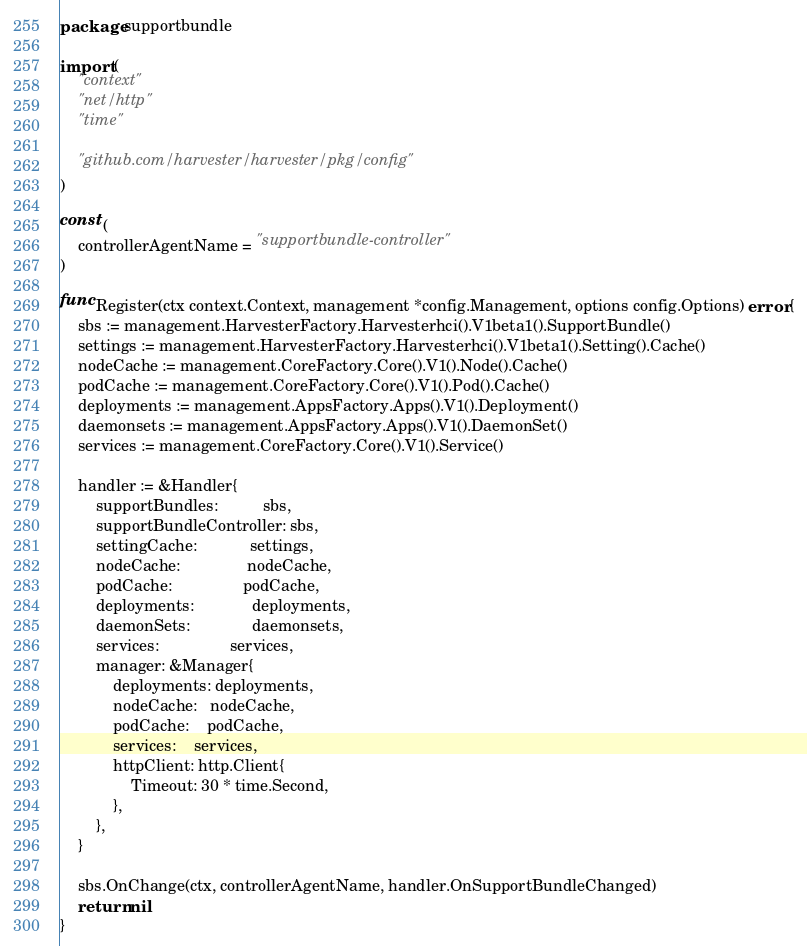<code> <loc_0><loc_0><loc_500><loc_500><_Go_>package supportbundle

import (
	"context"
	"net/http"
	"time"

	"github.com/harvester/harvester/pkg/config"
)

const (
	controllerAgentName = "supportbundle-controller"
)

func Register(ctx context.Context, management *config.Management, options config.Options) error {
	sbs := management.HarvesterFactory.Harvesterhci().V1beta1().SupportBundle()
	settings := management.HarvesterFactory.Harvesterhci().V1beta1().Setting().Cache()
	nodeCache := management.CoreFactory.Core().V1().Node().Cache()
	podCache := management.CoreFactory.Core().V1().Pod().Cache()
	deployments := management.AppsFactory.Apps().V1().Deployment()
	daemonsets := management.AppsFactory.Apps().V1().DaemonSet()
	services := management.CoreFactory.Core().V1().Service()

	handler := &Handler{
		supportBundles:          sbs,
		supportBundleController: sbs,
		settingCache:            settings,
		nodeCache:               nodeCache,
		podCache:                podCache,
		deployments:             deployments,
		daemonSets:              daemonsets,
		services:                services,
		manager: &Manager{
			deployments: deployments,
			nodeCache:   nodeCache,
			podCache:    podCache,
			services:    services,
			httpClient: http.Client{
				Timeout: 30 * time.Second,
			},
		},
	}

	sbs.OnChange(ctx, controllerAgentName, handler.OnSupportBundleChanged)
	return nil
}
</code> 